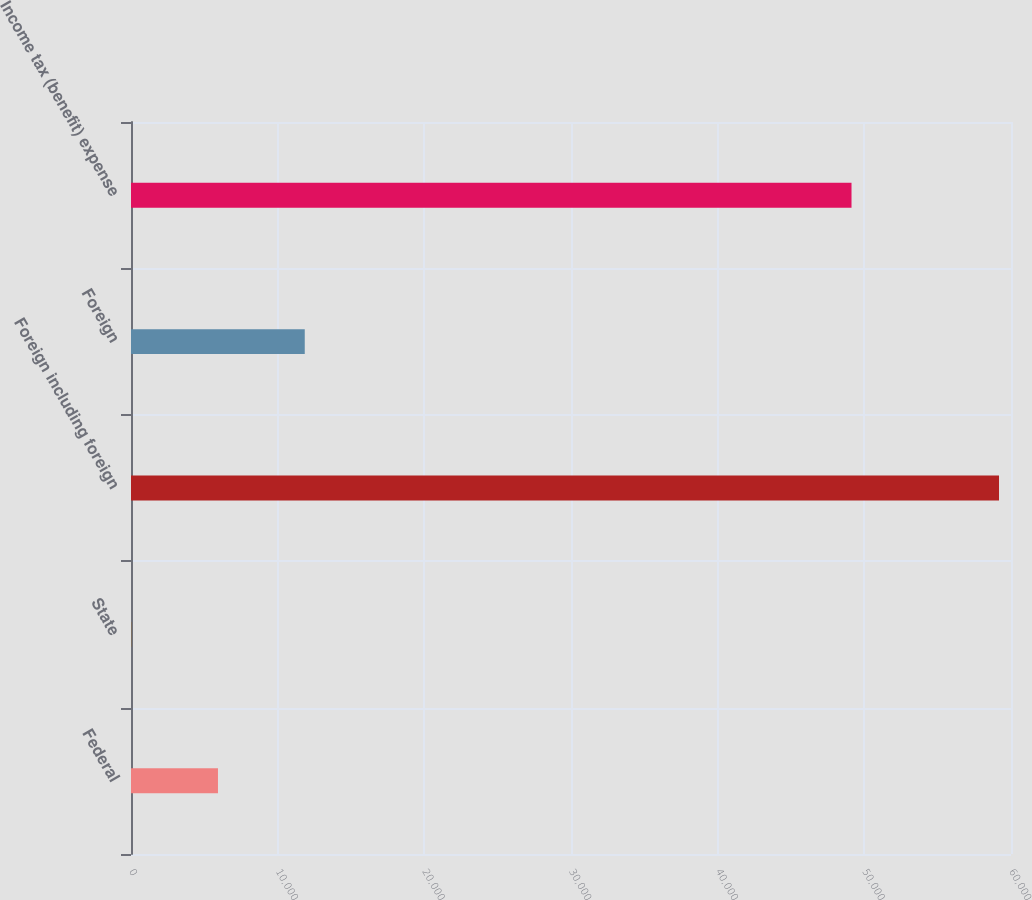<chart> <loc_0><loc_0><loc_500><loc_500><bar_chart><fcel>Federal<fcel>State<fcel>Foreign including foreign<fcel>Foreign<fcel>Income tax (benefit) expense<nl><fcel>5930<fcel>13<fcel>59183<fcel>11847<fcel>49126<nl></chart> 